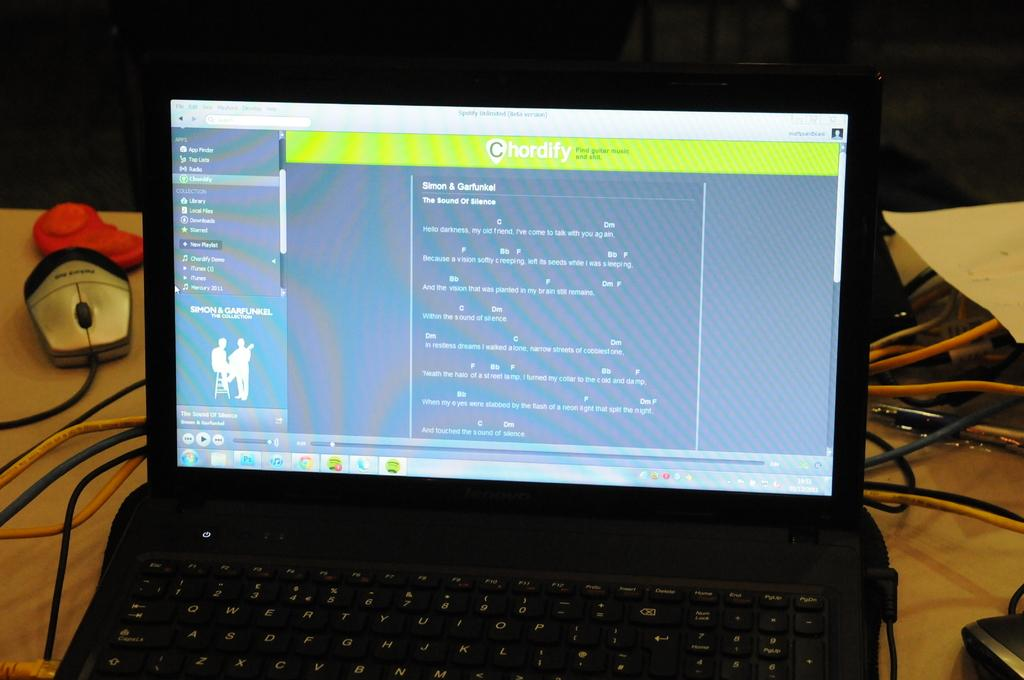Provide a one-sentence caption for the provided image. a chordify web site being displayed on a laptop. 